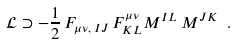<formula> <loc_0><loc_0><loc_500><loc_500>\mathcal { L } \supset - \frac { 1 } { 2 } \, F _ { \mu \nu , \, I J } \, F ^ { \mu \nu } _ { K L } M ^ { I L } \, M ^ { J K } \ .</formula> 